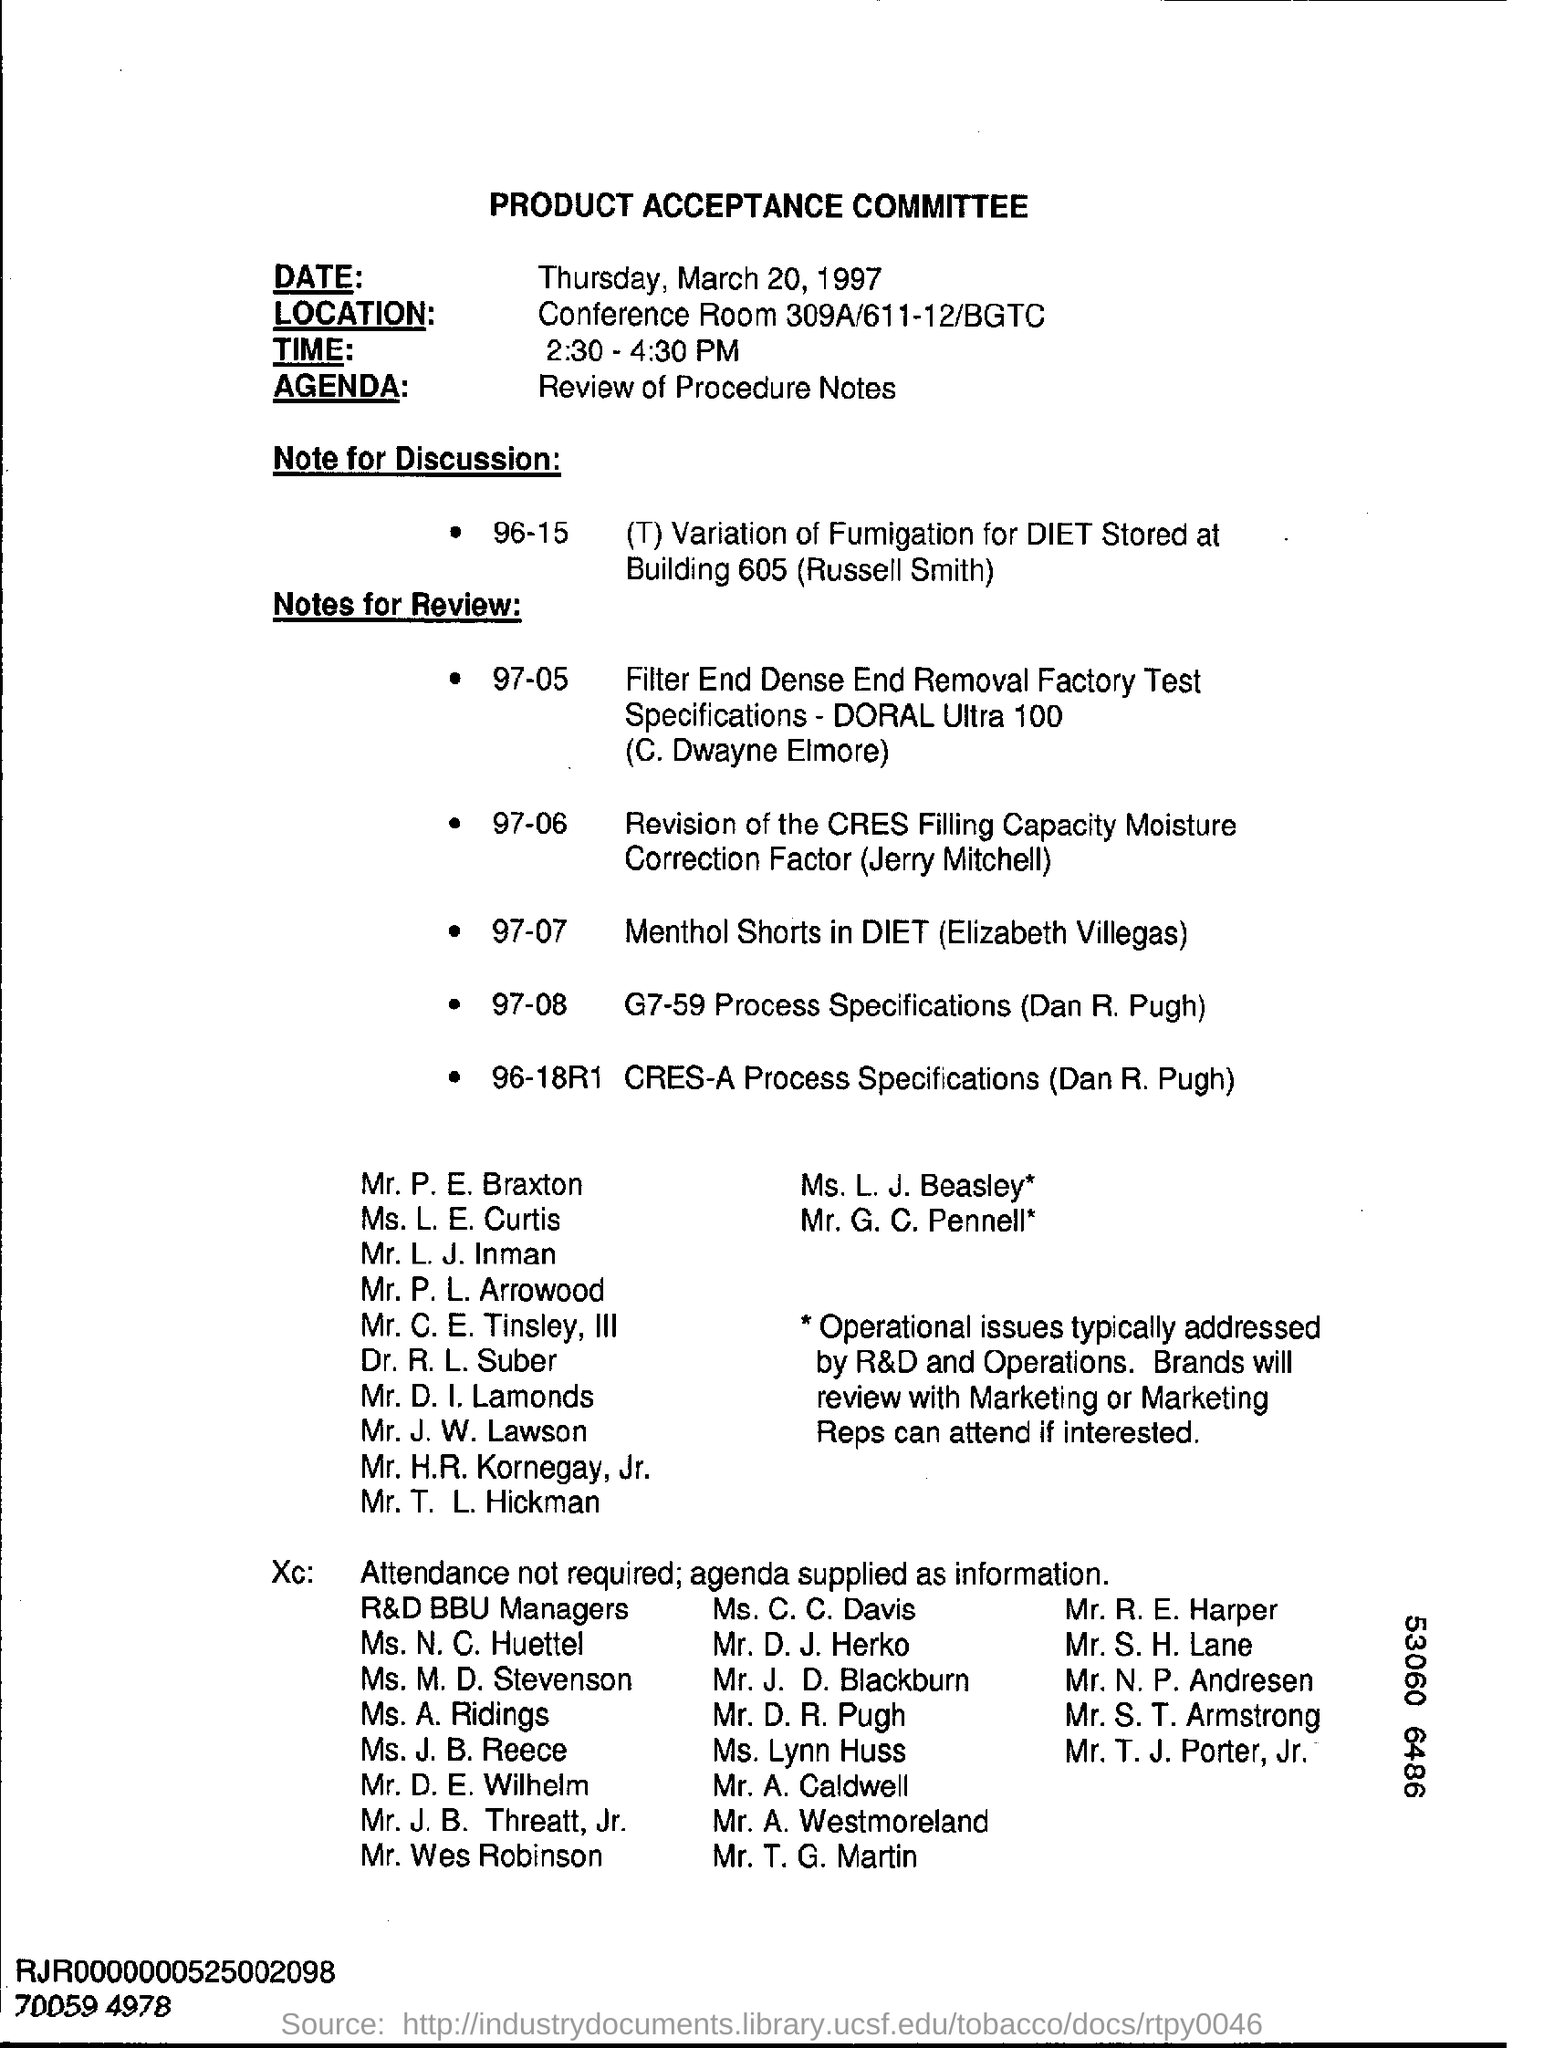Indicate a few pertinent items in this graphic. The time mentioned in this document is from 2:30 PM to 4:30 PM. The main title of this document is "Product Acceptance Committee". The agenda, as per the document, is to review the procedure notes. The date mentioned in the document is Thursday, March 20, 1997. The location specified in the document is Conference Room 309A/611-12/BGTC. 